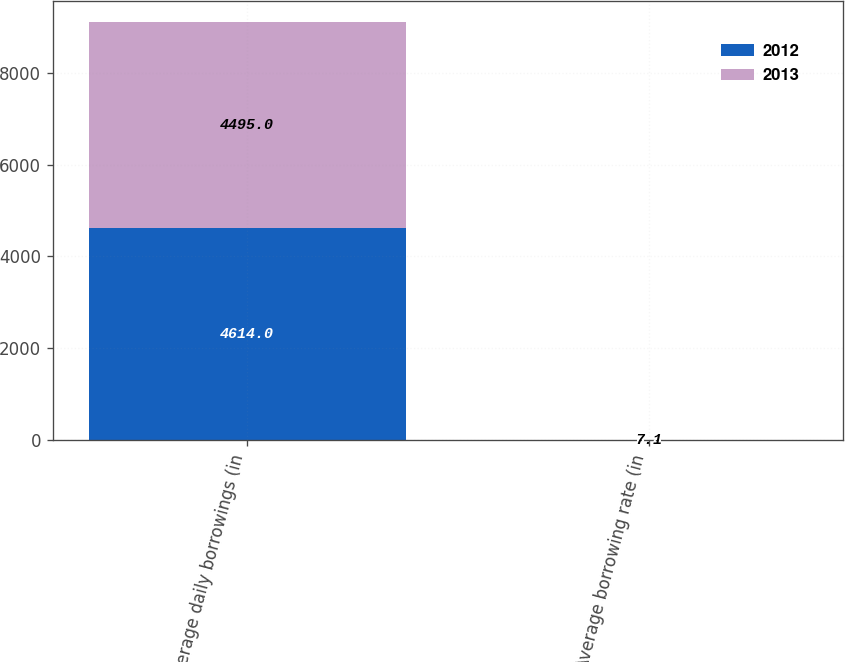Convert chart. <chart><loc_0><loc_0><loc_500><loc_500><stacked_bar_chart><ecel><fcel>Average daily borrowings (in<fcel>Average borrowing rate (in<nl><fcel>2012<fcel>4614<fcel>6.8<nl><fcel>2013<fcel>4495<fcel>7.1<nl></chart> 